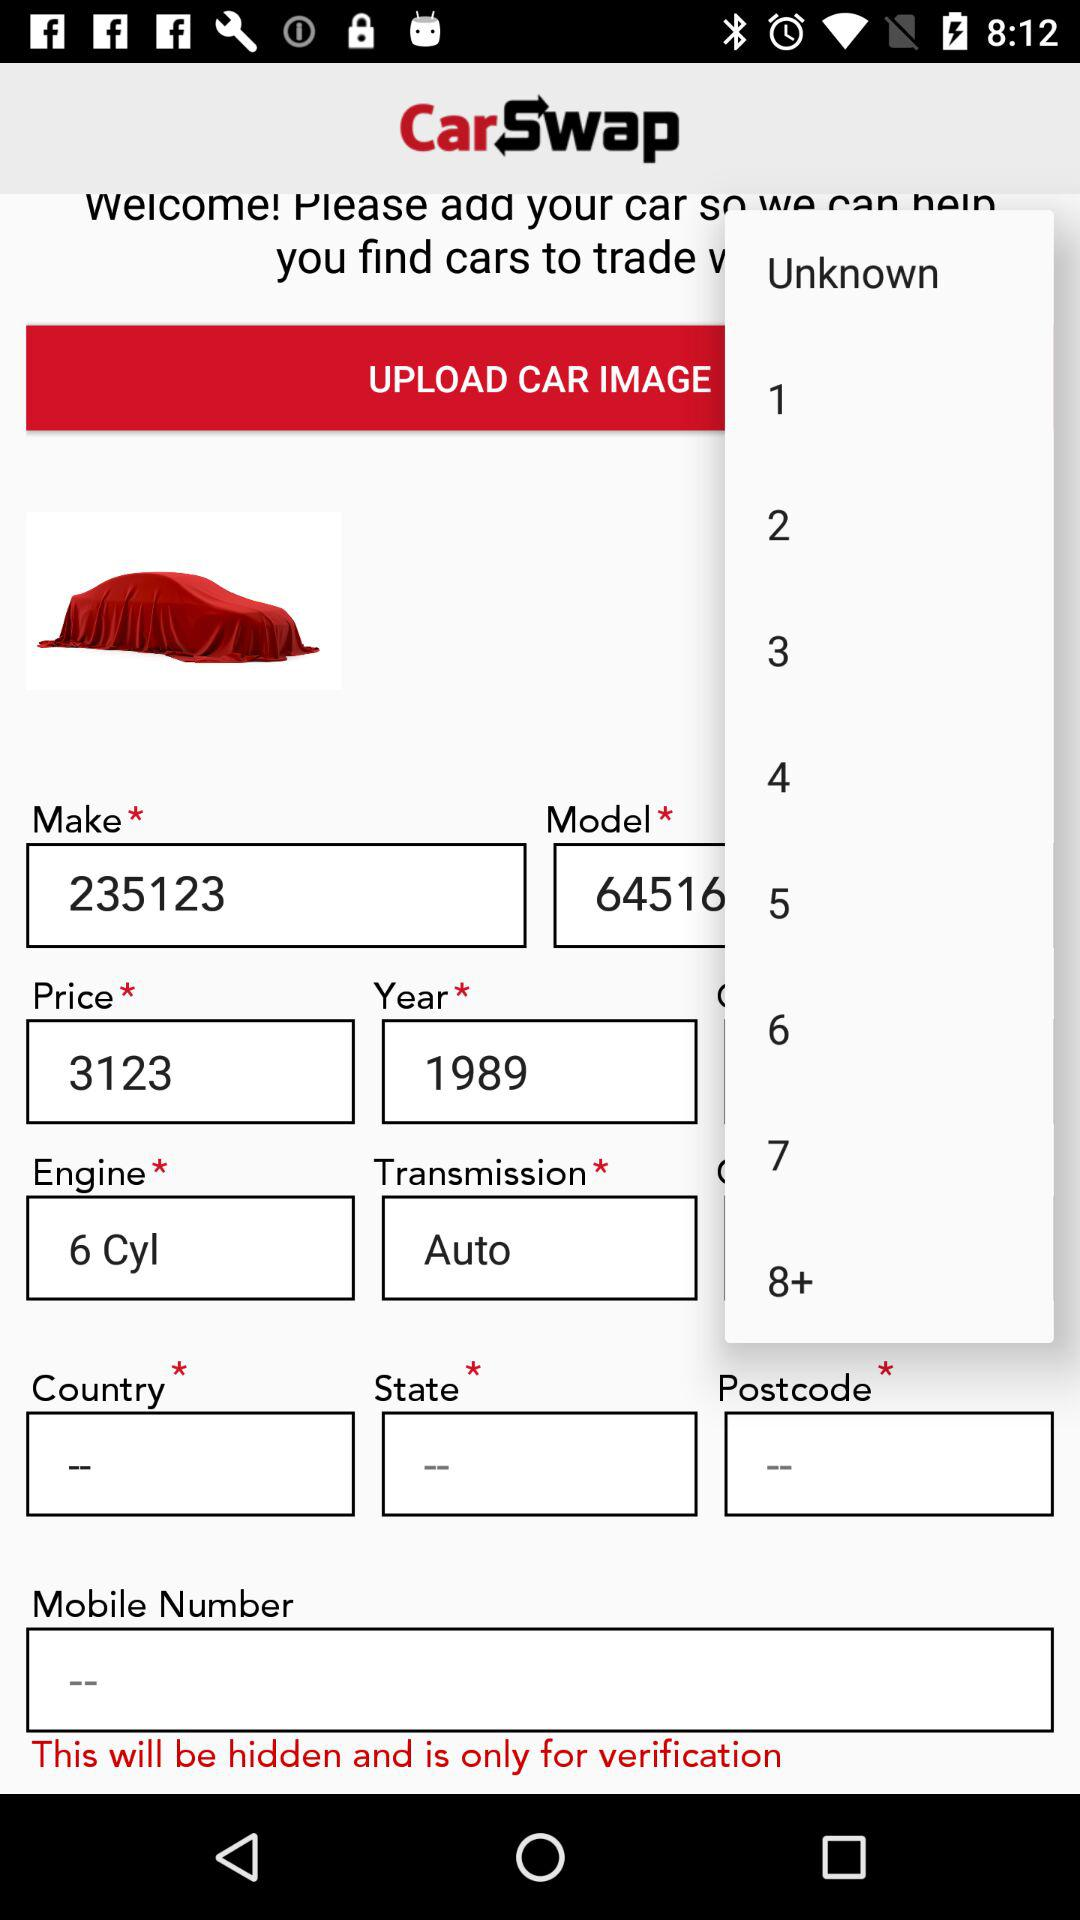What is the "Make" number? The "Make" number is 235123. 